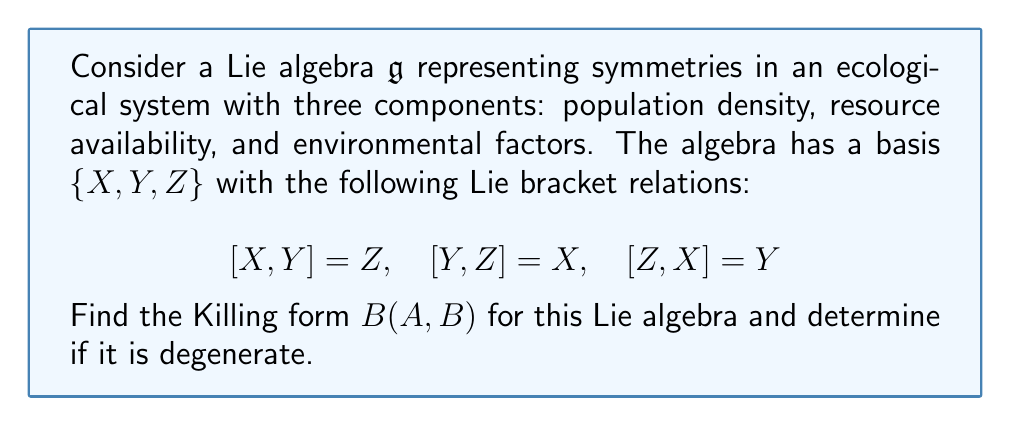Can you solve this math problem? To find the Killing form for this Lie algebra, we need to follow these steps:

1) The Killing form is defined as $B(A, B) = \text{tr}(\text{ad}(A) \circ \text{ad}(B))$, where $\text{ad}(A)$ is the adjoint representation of $A$.

2) First, let's calculate the adjoint representations for each basis element:

   For $X$: $\text{ad}(X)Y = [X, Y] = Z$, $\text{ad}(X)Z = [X, Z] = -Y$
   $$\text{ad}(X) = \begin{pmatrix} 0 & 0 & 0 \\ 0 & 0 & -1 \\ 0 & 1 & 0 \end{pmatrix}$$

   For $Y$: $\text{ad}(Y)Z = [Y, Z] = X$, $\text{ad}(Y)X = [Y, X] = -Z$
   $$\text{ad}(Y) = \begin{pmatrix} 0 & 0 & 1 \\ 0 & 0 & 0 \\ -1 & 0 & 0 \end{pmatrix}$$

   For $Z$: $\text{ad}(Z)X = [Z, X] = Y$, $\text{ad}(Z)Y = [Z, Y] = -X$
   $$\text{ad}(Z) = \begin{pmatrix} 0 & -1 & 0 \\ 1 & 0 & 0 \\ 0 & 0 & 0 \end{pmatrix}$$

3) Now, we calculate $B(X, X)$, $B(Y, Y)$, $B(Z, Z)$, $B(X, Y)$, $B(Y, Z)$, and $B(X, Z)$:

   $B(X, X) = \text{tr}(\text{ad}(X) \circ \text{ad}(X)) = -2$
   $B(Y, Y) = \text{tr}(\text{ad}(Y) \circ \text{ad}(Y)) = -2$
   $B(Z, Z) = \text{tr}(\text{ad}(Z) \circ \text{ad}(Z)) = -2$
   $B(X, Y) = \text{tr}(\text{ad}(X) \circ \text{ad}(Y)) = 0$
   $B(Y, Z) = \text{tr}(\text{ad}(Y) \circ \text{ad}(Z)) = 0$
   $B(X, Z) = \text{tr}(\text{ad}(X) \circ \text{ad}(Z)) = 0$

4) The Killing form can be represented as a matrix:

   $$B = \begin{pmatrix} -2 & 0 & 0 \\ 0 & -2 & 0 \\ 0 & 0 & -2 \end{pmatrix}$$

5) To determine if the Killing form is degenerate, we check its determinant:

   $\det(B) = (-2)^3 = -8 \neq 0$

   Since the determinant is non-zero, the Killing form is non-degenerate.
Answer: The Killing form for the given Lie algebra is:

$$B = \begin{pmatrix} -2 & 0 & 0 \\ 0 & -2 & 0 \\ 0 & 0 & -2 \end{pmatrix}$$

The Killing form is non-degenerate. 